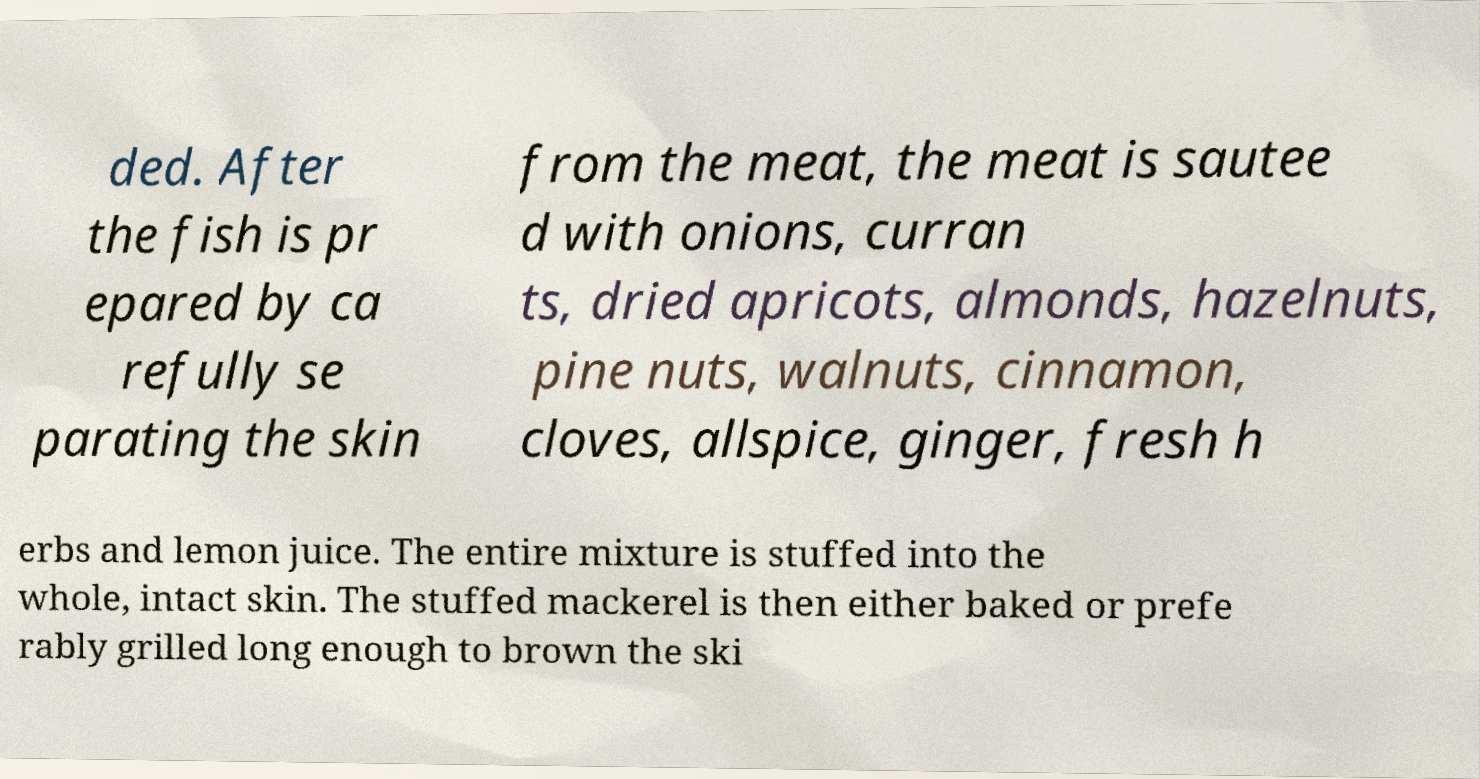I need the written content from this picture converted into text. Can you do that? ded. After the fish is pr epared by ca refully se parating the skin from the meat, the meat is sautee d with onions, curran ts, dried apricots, almonds, hazelnuts, pine nuts, walnuts, cinnamon, cloves, allspice, ginger, fresh h erbs and lemon juice. The entire mixture is stuffed into the whole, intact skin. The stuffed mackerel is then either baked or prefe rably grilled long enough to brown the ski 